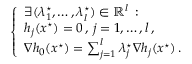Convert formula to latex. <formula><loc_0><loc_0><loc_500><loc_500>\left \{ \begin{array} { l l } { \exists ( \lambda _ { 1 } ^ { ^ { * } } , \dots , \lambda _ { l } ^ { ^ { * } } ) \in { \mathbb { R } } ^ { l } \, \colon } \\ { h _ { j } ( x ^ { ^ { * } } ) = 0 \, , \, j = 1 , \dots , l \, , } \\ { \nabla h _ { 0 } ( x ^ { ^ { * } } ) = \sum _ { j = 1 } ^ { l } \lambda _ { j } ^ { ^ { * } } \nabla h _ { j } ( x ^ { ^ { * } } ) \, . } \end{array}</formula> 